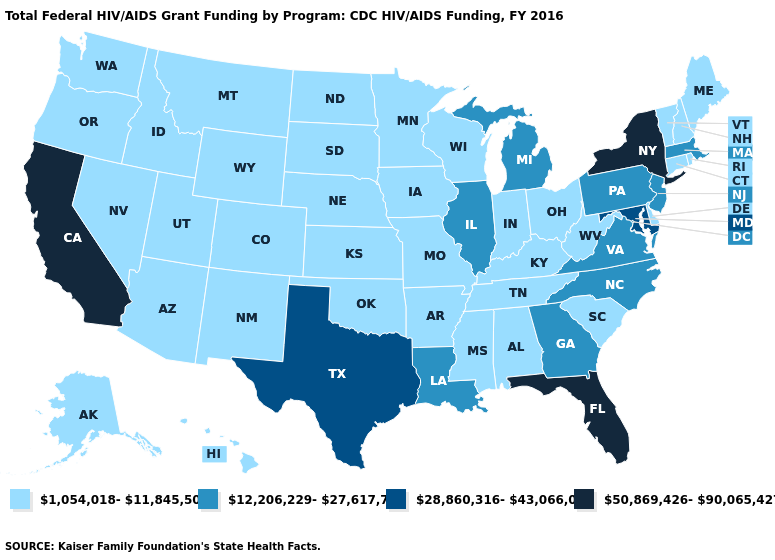What is the value of Rhode Island?
Quick response, please. 1,054,018-11,845,500. Does New York have the highest value in the Northeast?
Short answer required. Yes. Does Wyoming have the lowest value in the West?
Write a very short answer. Yes. Name the states that have a value in the range 28,860,316-43,066,029?
Answer briefly. Maryland, Texas. What is the lowest value in the South?
Answer briefly. 1,054,018-11,845,500. Does Virginia have the lowest value in the USA?
Be succinct. No. Name the states that have a value in the range 1,054,018-11,845,500?
Short answer required. Alabama, Alaska, Arizona, Arkansas, Colorado, Connecticut, Delaware, Hawaii, Idaho, Indiana, Iowa, Kansas, Kentucky, Maine, Minnesota, Mississippi, Missouri, Montana, Nebraska, Nevada, New Hampshire, New Mexico, North Dakota, Ohio, Oklahoma, Oregon, Rhode Island, South Carolina, South Dakota, Tennessee, Utah, Vermont, Washington, West Virginia, Wisconsin, Wyoming. How many symbols are there in the legend?
Be succinct. 4. What is the value of South Dakota?
Keep it brief. 1,054,018-11,845,500. What is the value of Colorado?
Quick response, please. 1,054,018-11,845,500. Among the states that border Wisconsin , which have the lowest value?
Write a very short answer. Iowa, Minnesota. Name the states that have a value in the range 50,869,426-90,065,427?
Keep it brief. California, Florida, New York. Which states hav the highest value in the Northeast?
Answer briefly. New York. Among the states that border Indiana , does Michigan have the lowest value?
Quick response, please. No. Name the states that have a value in the range 1,054,018-11,845,500?
Be succinct. Alabama, Alaska, Arizona, Arkansas, Colorado, Connecticut, Delaware, Hawaii, Idaho, Indiana, Iowa, Kansas, Kentucky, Maine, Minnesota, Mississippi, Missouri, Montana, Nebraska, Nevada, New Hampshire, New Mexico, North Dakota, Ohio, Oklahoma, Oregon, Rhode Island, South Carolina, South Dakota, Tennessee, Utah, Vermont, Washington, West Virginia, Wisconsin, Wyoming. 